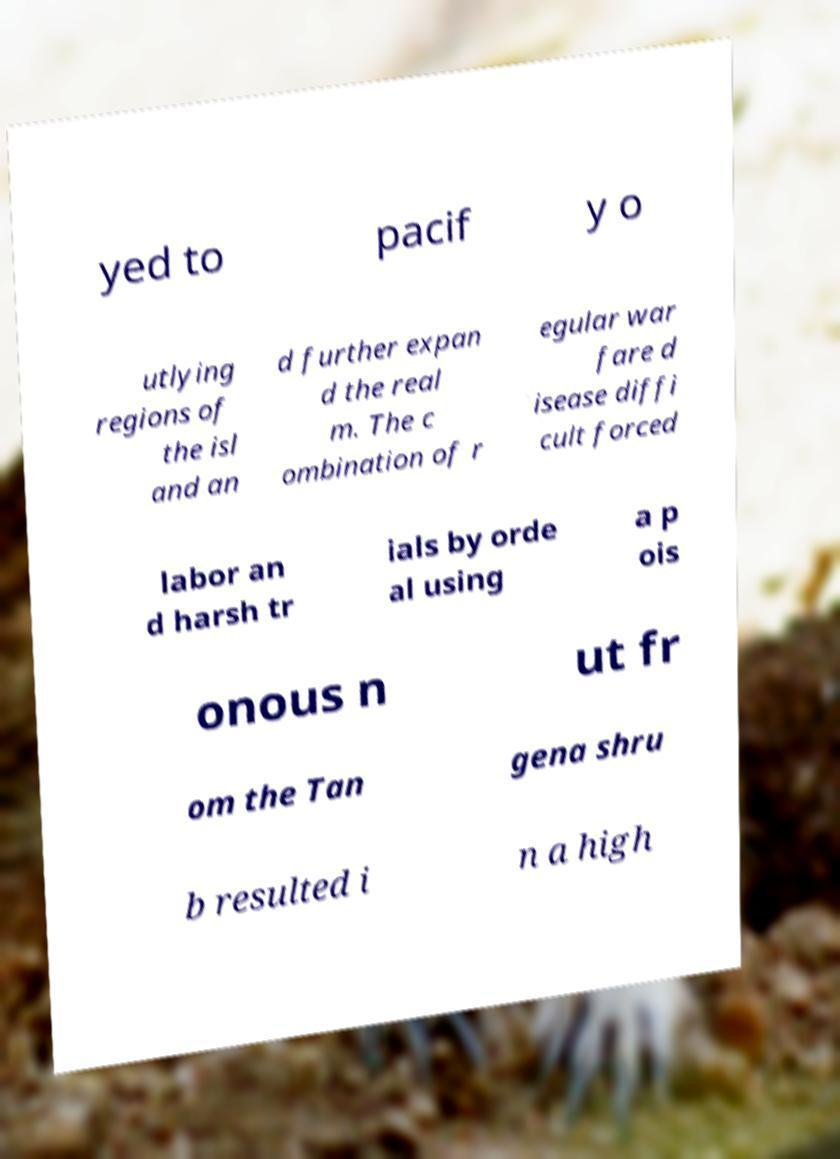Could you extract and type out the text from this image? yed to pacif y o utlying regions of the isl and an d further expan d the real m. The c ombination of r egular war fare d isease diffi cult forced labor an d harsh tr ials by orde al using a p ois onous n ut fr om the Tan gena shru b resulted i n a high 